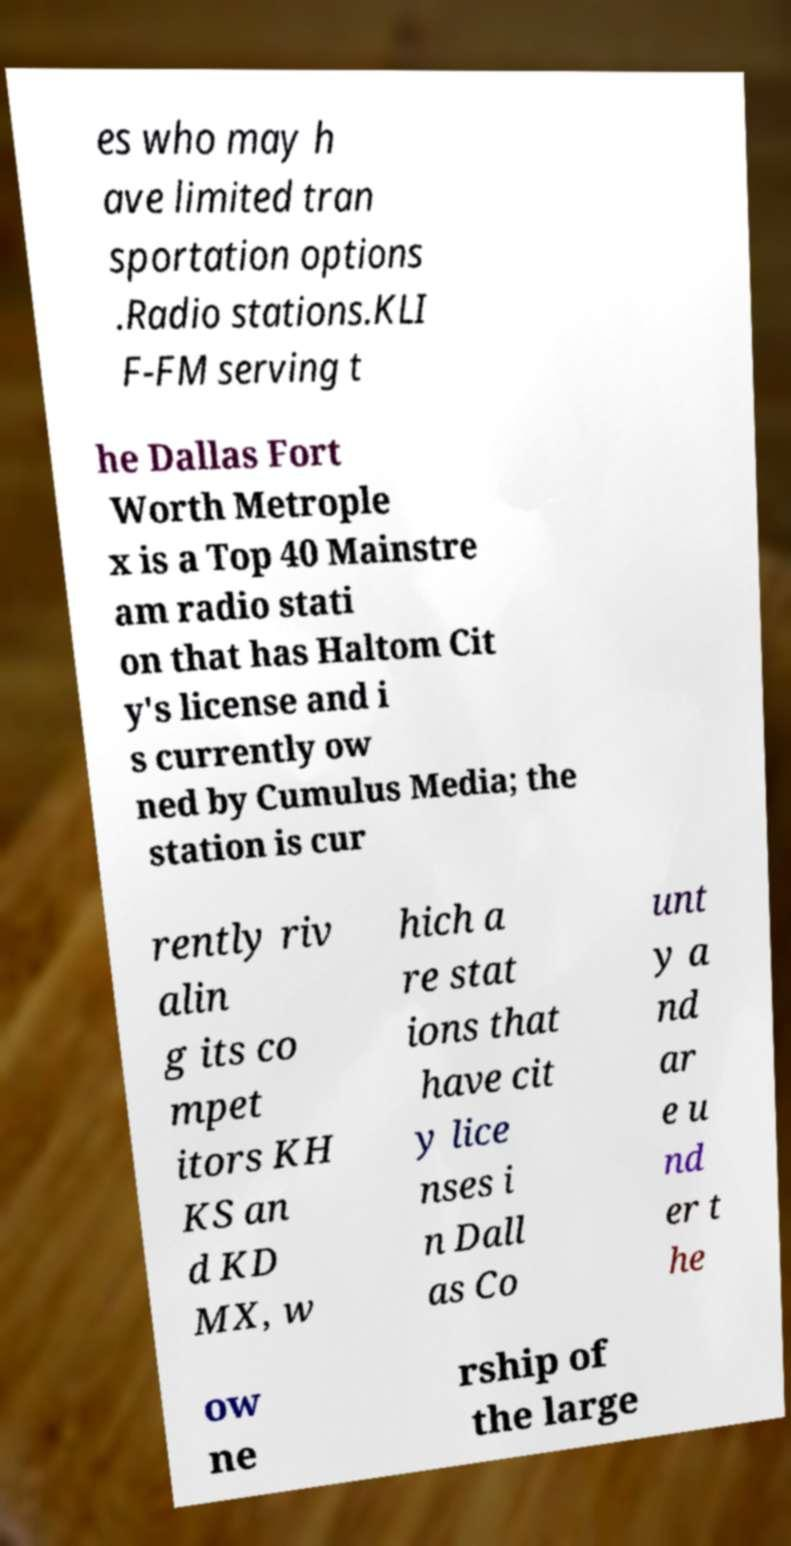What messages or text are displayed in this image? I need them in a readable, typed format. es who may h ave limited tran sportation options .Radio stations.KLI F-FM serving t he Dallas Fort Worth Metrople x is a Top 40 Mainstre am radio stati on that has Haltom Cit y's license and i s currently ow ned by Cumulus Media; the station is cur rently riv alin g its co mpet itors KH KS an d KD MX, w hich a re stat ions that have cit y lice nses i n Dall as Co unt y a nd ar e u nd er t he ow ne rship of the large 